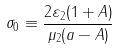Convert formula to latex. <formula><loc_0><loc_0><loc_500><loc_500>\sigma _ { 0 } \equiv \frac { 2 \varepsilon _ { 2 } ( 1 + A ) } { \mu _ { 2 } ( a - A ) }</formula> 